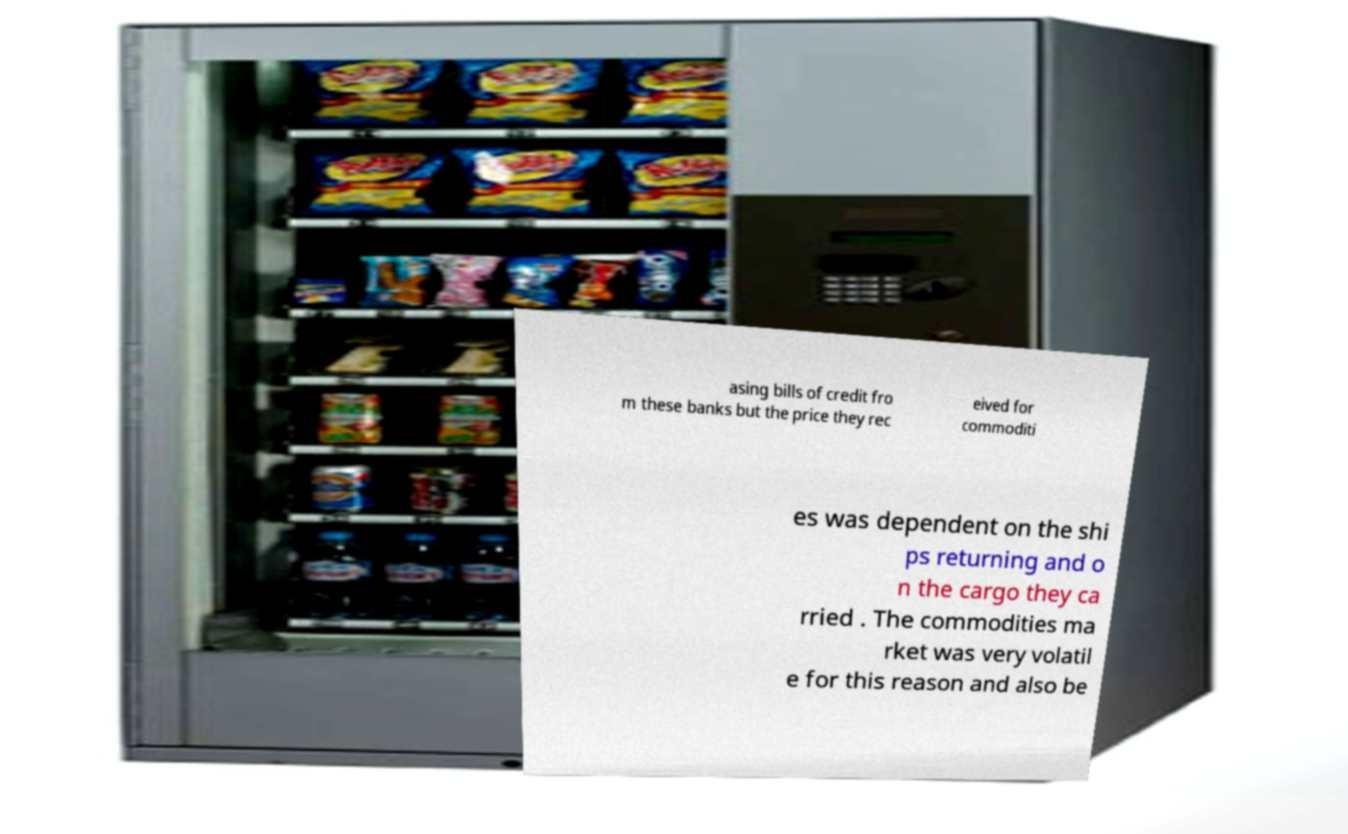For documentation purposes, I need the text within this image transcribed. Could you provide that? asing bills of credit fro m these banks but the price they rec eived for commoditi es was dependent on the shi ps returning and o n the cargo they ca rried . The commodities ma rket was very volatil e for this reason and also be 